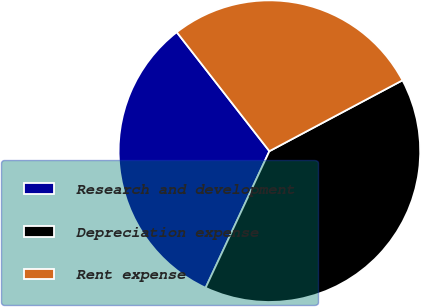<chart> <loc_0><loc_0><loc_500><loc_500><pie_chart><fcel>Research and development<fcel>Depreciation expense<fcel>Rent expense<nl><fcel>32.52%<fcel>39.74%<fcel>27.74%<nl></chart> 